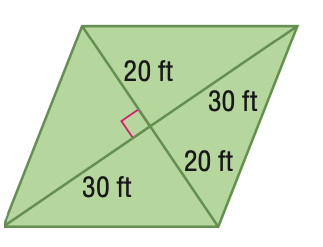Answer the mathemtical geometry problem and directly provide the correct option letter.
Question: Find the area of the figure. Round to the nearest tenth if necessary.
Choices: A: 600 B: 900 C: 1200 D: 2400 C 